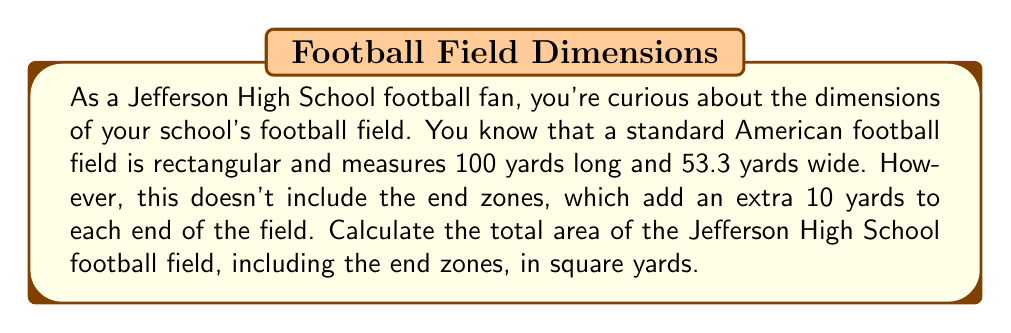Can you answer this question? Let's approach this step-by-step:

1) First, we need to determine the total length of the field including the end zones:
   $$\text{Total length} = 100 \text{ yards} + 10 \text{ yards} + 10 \text{ yards} = 120 \text{ yards}$$

2) The width of the field remains constant at 53.3 yards.

3) Now we can use the formula for the area of a rectangle:
   $$A = l \times w$$
   Where $A$ is the area, $l$ is the length, and $w$ is the width.

4) Substituting our values:
   $$A = 120 \text{ yards} \times 53.3 \text{ yards}$$

5) Calculating:
   $$A = 6,396 \text{ square yards}$$

[asy]
unitsize(1cm);
draw((0,0)--(12,0)--(12,5.33)--(0,5.33)--cycle);
draw((1,0)--(1,5.33));
draw((11,0)--(11,5.33));
label("120 yards", (6,-0.5));
label("53.3 yards", (-0.5,2.665), W);
label("10 yards", (0.5,2.665));
label("100 yards", (6,2.665));
label("10 yards", (11.5,2.665));
[/asy]
Answer: The total area of the Jefferson High School football field, including end zones, is 6,396 square yards. 